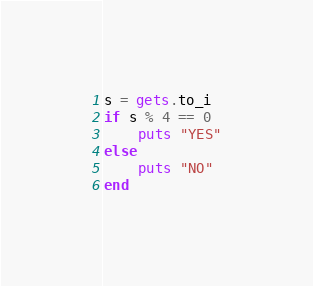Convert code to text. <code><loc_0><loc_0><loc_500><loc_500><_Ruby_>s = gets.to_i
if s % 4 == 0
    puts "YES"
else
    puts "NO"
end
</code> 